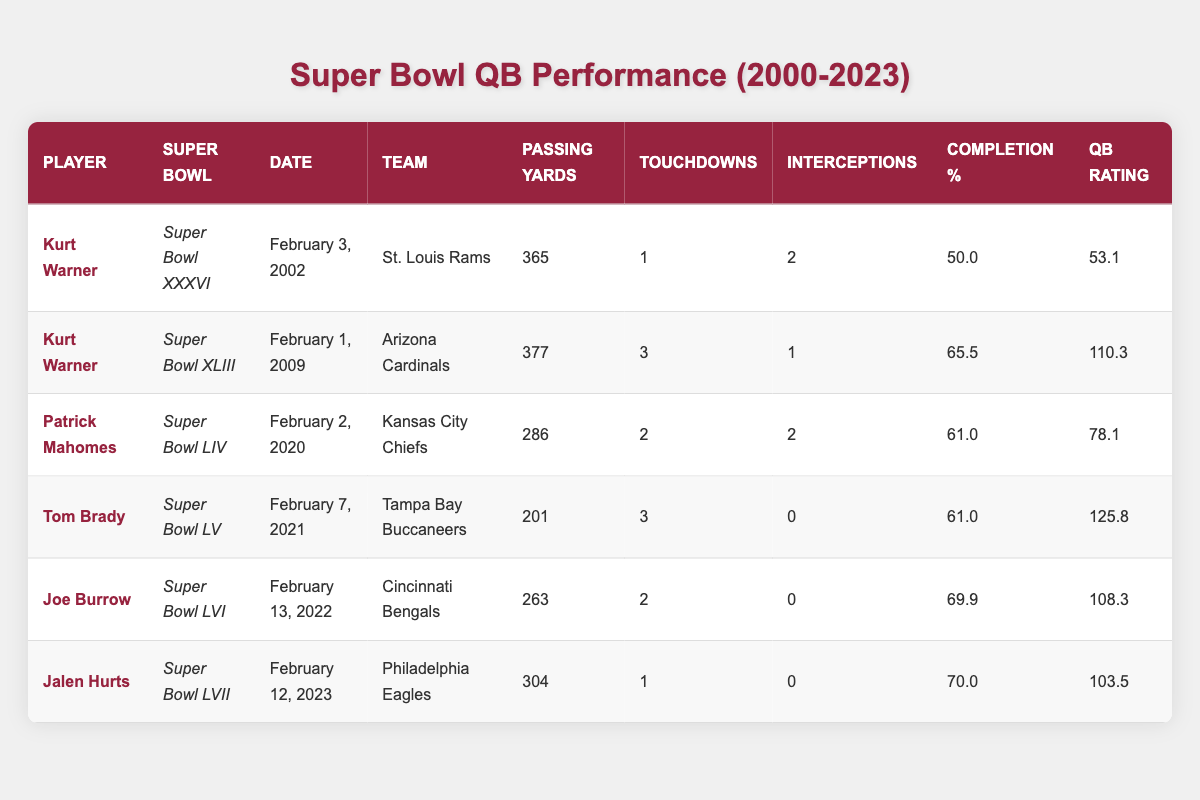What is the highest quarterback rating achieved among the players listed? The highest quarterback rating in the table is 125.8, achieved by Tom Brady in Super Bowl LV.
Answer: 125.8 Which player had the most passing yards in a Super Bowl? Kurt Warner had the most passing yards with 377 in Super Bowl XLIII.
Answer: 377 How many touchdowns did Jalen Hurts throw in Super Bowl LVII? Jalen Hurts threw 1 touchdown in Super Bowl LVII.
Answer: 1 What is the average completion percentage of the players in this table? To find the average completion percentage, sum the completion percentages (50.0 + 65.5 + 61.0 + 61.0 + 69.9 + 70.0 = 397.4) then divide by the number of players (6), which gives 397.4 / 6 = 66.23.
Answer: 66.23 Did any player record zero interceptions in the Super Bowl? Yes, Tom Brady, Joe Burrow, and Jalen Hurts all recorded zero interceptions in their respective Super Bowls.
Answer: Yes What was the difference in passing yards between Kurt Warner's two Super Bowl appearances? Kurt Warner had 365 passing yards in Super Bowl XXXVI and 377 in Super Bowl XLIII. The difference is 377 - 365 = 12 yards.
Answer: 12 Which player's performance metrics show the highest number of touchdowns in a Super Bowl? Kurt Warner's performance in Super Bowl XLIII shows the highest number of touchdowns with 3.
Answer: 3 What was Patrick Mahomes' completion percentage in Super Bowl LIV? Patrick Mahomes had a completion percentage of 61.0 in Super Bowl LIV.
Answer: 61.0 How many Super Bowls did Kurt Warner play in according to the data? Kurt Warner played in two Super Bowls (XXXVI and XLIII).
Answer: 2 Which Super Bowl had the lowest passing yards recorded by a player? Super Bowl LV had the lowest passing yards with 201 by Tom Brady.
Answer: 201 What is the combined total of touchdowns thrown by all players in the table? The total number of touchdowns is (1 + 3 + 2 + 3 + 2 + 1) = 12.
Answer: 12 